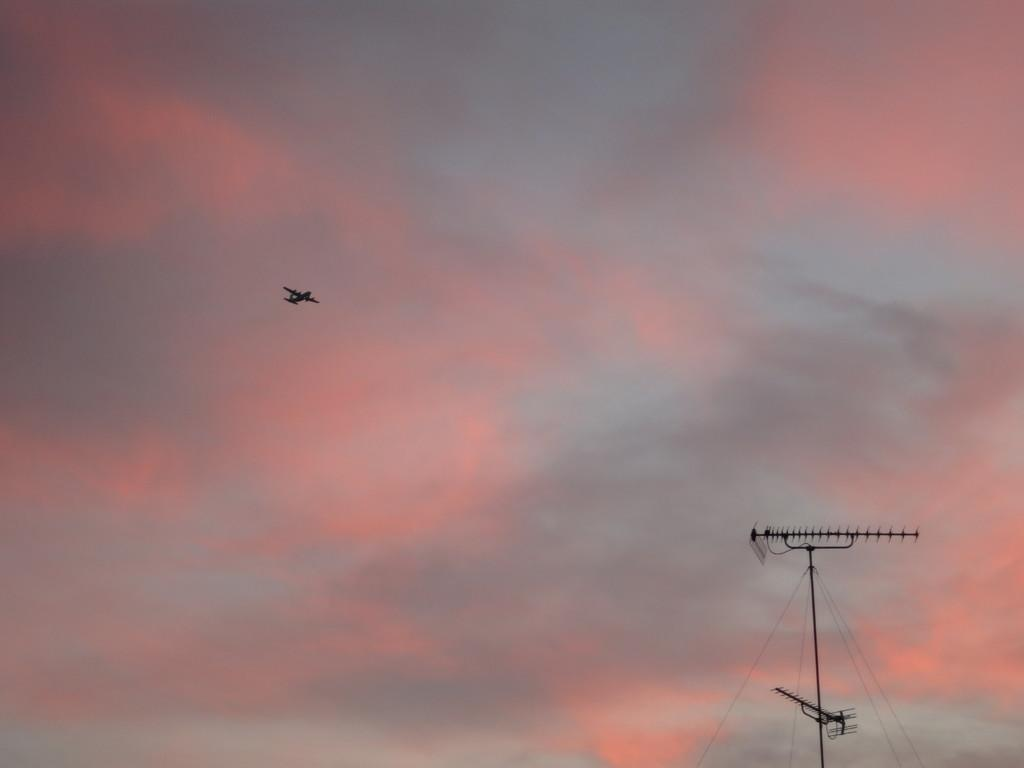What type of structure is present in the image? There is a power station in the image. What else can be seen in the image besides the power station? There is an aeroplane in the image. What part of the natural environment is visible in the image? The sky is visible in the image. What color is the shirt worn by the bee in the image? There is no bee or shirt present in the image. How does the aeroplane affect the throat of the power station in the image? The image does not depict any interaction between the aeroplane and the power station, nor does it show any indication of the power station having a throat. 